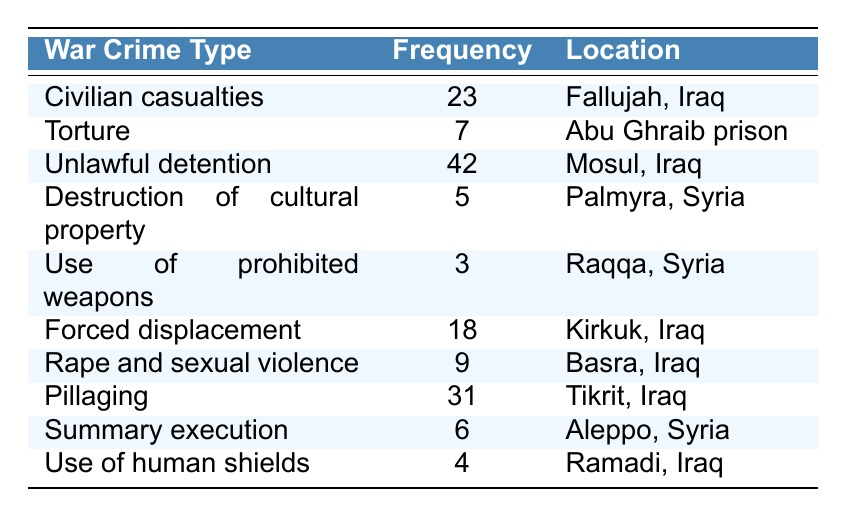What is the most frequently recorded war crime in the table? The table shows that the war crime with the highest frequency is "Unlawful detention," which has a frequency of 42.
Answer: Unlawful detention How many instances of civilian casualties were recorded? According to the table, there were 23 instances of civilian casualties recorded in Fallujah, Iraq.
Answer: 23 What is the total number of recorded instances of torture and summary execution? To find this, we add the frequencies of torture (7) and summary execution (6), which gives us a total of 13 (7 + 6 = 13).
Answer: 13 Which location had the highest number of different types of recorded war crimes? By examining the table, we see that Mosul, Iraq, has the highest number of different types, with "Unlawful detention" and "Forced displacement" recorded there.
Answer: Mosul, Iraq Is there a recorded instance of the use of prohibited weapons? Yes, the table lists "Use of prohibited weapons," with a frequency of 3, indicating it was recorded.
Answer: Yes What is the average frequency of war crimes recorded in Tikrit, Iraq, and Basra, Iraq? The table lists "Pillaging" in Tikrit with a frequency of 31 and "Rape and sexual violence" in Basra with a frequency of 9. Adding these frequencies gives 40 (31 + 9 = 40), and dividing by 2 gives an average of 20 (40 / 2 = 20).
Answer: 20 How many war crimes were recorded in Iraq compared to Syria? In Iraq, the table lists 5 recorded instances (Civilian casualties - 23, Unlawful detention - 42, Forced displacement - 18, Rape and sexual violence - 9, Pillaging - 31). In Syria, 3 instances were recorded (Destruction of cultural property - 5, Use of prohibited weapons - 3, Summary execution - 6). The total for Iraq is 123 and for Syria is 14, therefore, 123 (Iraq) - 14 (Syria) = 109.
Answer: 109 What type of war crime was least frequently recorded, and where did it occur? The type of war crime least frequently recorded is "Use of prohibited weapons," with a frequency of 3, occurring in Raqqa, Syria.
Answer: Use of prohibited weapons in Raqqa, Syria How does the frequency of forced displacement compare to that of rape and sexual violence? "Forced displacement" has a frequency of 18, whereas "Rape and sexual violence" has a frequency of 9. Comparing these, 18 is greater than 9, so there were more instances of forced displacement than rape and sexual violence (18 - 9 = 9).
Answer: Forced displacement is greater by 9 instances 